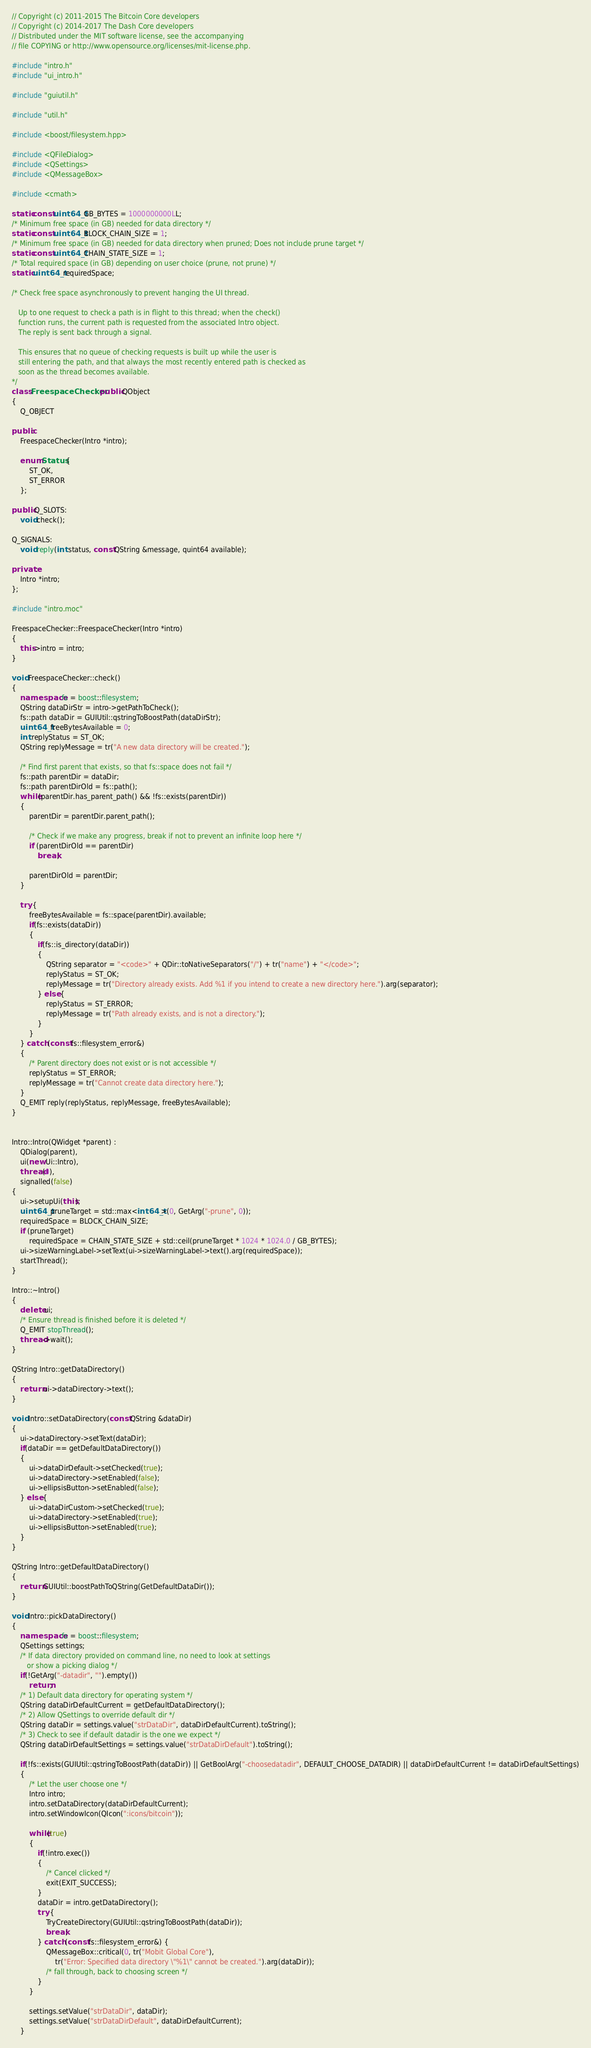Convert code to text. <code><loc_0><loc_0><loc_500><loc_500><_C++_>// Copyright (c) 2011-2015 The Bitcoin Core developers
// Copyright (c) 2014-2017 The Dash Core developers
// Distributed under the MIT software license, see the accompanying
// file COPYING or http://www.opensource.org/licenses/mit-license.php.

#include "intro.h"
#include "ui_intro.h"

#include "guiutil.h"

#include "util.h"

#include <boost/filesystem.hpp>

#include <QFileDialog>
#include <QSettings>
#include <QMessageBox>

#include <cmath>

static const uint64_t GB_BYTES = 1000000000LL;
/* Minimum free space (in GB) needed for data directory */
static const uint64_t BLOCK_CHAIN_SIZE = 1;
/* Minimum free space (in GB) needed for data directory when pruned; Does not include prune target */
static const uint64_t CHAIN_STATE_SIZE = 1;
/* Total required space (in GB) depending on user choice (prune, not prune) */
static uint64_t requiredSpace;

/* Check free space asynchronously to prevent hanging the UI thread.

   Up to one request to check a path is in flight to this thread; when the check()
   function runs, the current path is requested from the associated Intro object.
   The reply is sent back through a signal.

   This ensures that no queue of checking requests is built up while the user is
   still entering the path, and that always the most recently entered path is checked as
   soon as the thread becomes available.
*/
class FreespaceChecker : public QObject
{
    Q_OBJECT

public:
    FreespaceChecker(Intro *intro);

    enum Status {
        ST_OK,
        ST_ERROR
    };

public Q_SLOTS:
    void check();

Q_SIGNALS:
    void reply(int status, const QString &message, quint64 available);

private:
    Intro *intro;
};

#include "intro.moc"

FreespaceChecker::FreespaceChecker(Intro *intro)
{
    this->intro = intro;
}

void FreespaceChecker::check()
{
    namespace fs = boost::filesystem;
    QString dataDirStr = intro->getPathToCheck();
    fs::path dataDir = GUIUtil::qstringToBoostPath(dataDirStr);
    uint64_t freeBytesAvailable = 0;
    int replyStatus = ST_OK;
    QString replyMessage = tr("A new data directory will be created.");

    /* Find first parent that exists, so that fs::space does not fail */
    fs::path parentDir = dataDir;
    fs::path parentDirOld = fs::path();
    while(parentDir.has_parent_path() && !fs::exists(parentDir))
    {
        parentDir = parentDir.parent_path();

        /* Check if we make any progress, break if not to prevent an infinite loop here */
        if (parentDirOld == parentDir)
            break;

        parentDirOld = parentDir;
    }

    try {
        freeBytesAvailable = fs::space(parentDir).available;
        if(fs::exists(dataDir))
        {
            if(fs::is_directory(dataDir))
            {
                QString separator = "<code>" + QDir::toNativeSeparators("/") + tr("name") + "</code>";
                replyStatus = ST_OK;
                replyMessage = tr("Directory already exists. Add %1 if you intend to create a new directory here.").arg(separator);
            } else {
                replyStatus = ST_ERROR;
                replyMessage = tr("Path already exists, and is not a directory.");
            }
        }
    } catch (const fs::filesystem_error&)
    {
        /* Parent directory does not exist or is not accessible */
        replyStatus = ST_ERROR;
        replyMessage = tr("Cannot create data directory here.");
    }
    Q_EMIT reply(replyStatus, replyMessage, freeBytesAvailable);
}


Intro::Intro(QWidget *parent) :
    QDialog(parent),
    ui(new Ui::Intro),
    thread(0),
    signalled(false)
{
    ui->setupUi(this);
    uint64_t pruneTarget = std::max<int64_t>(0, GetArg("-prune", 0));
    requiredSpace = BLOCK_CHAIN_SIZE;
    if (pruneTarget)
        requiredSpace = CHAIN_STATE_SIZE + std::ceil(pruneTarget * 1024 * 1024.0 / GB_BYTES);
    ui->sizeWarningLabel->setText(ui->sizeWarningLabel->text().arg(requiredSpace));
    startThread();
}

Intro::~Intro()
{
    delete ui;
    /* Ensure thread is finished before it is deleted */
    Q_EMIT stopThread();
    thread->wait();
}

QString Intro::getDataDirectory()
{
    return ui->dataDirectory->text();
}

void Intro::setDataDirectory(const QString &dataDir)
{
    ui->dataDirectory->setText(dataDir);
    if(dataDir == getDefaultDataDirectory())
    {
        ui->dataDirDefault->setChecked(true);
        ui->dataDirectory->setEnabled(false);
        ui->ellipsisButton->setEnabled(false);
    } else {
        ui->dataDirCustom->setChecked(true);
        ui->dataDirectory->setEnabled(true);
        ui->ellipsisButton->setEnabled(true);
    }
}

QString Intro::getDefaultDataDirectory()
{
    return GUIUtil::boostPathToQString(GetDefaultDataDir());
}

void Intro::pickDataDirectory()
{
    namespace fs = boost::filesystem;
    QSettings settings;
    /* If data directory provided on command line, no need to look at settings
       or show a picking dialog */
    if(!GetArg("-datadir", "").empty())
        return;
    /* 1) Default data directory for operating system */
    QString dataDirDefaultCurrent = getDefaultDataDirectory();
    /* 2) Allow QSettings to override default dir */
    QString dataDir = settings.value("strDataDir", dataDirDefaultCurrent).toString();
    /* 3) Check to see if default datadir is the one we expect */
    QString dataDirDefaultSettings = settings.value("strDataDirDefault").toString();

    if(!fs::exists(GUIUtil::qstringToBoostPath(dataDir)) || GetBoolArg("-choosedatadir", DEFAULT_CHOOSE_DATADIR) || dataDirDefaultCurrent != dataDirDefaultSettings)
    {
        /* Let the user choose one */
        Intro intro;
        intro.setDataDirectory(dataDirDefaultCurrent);
        intro.setWindowIcon(QIcon(":icons/bitcoin"));

        while(true)
        {
            if(!intro.exec())
            {
                /* Cancel clicked */
                exit(EXIT_SUCCESS);
            }
            dataDir = intro.getDataDirectory();
            try {
                TryCreateDirectory(GUIUtil::qstringToBoostPath(dataDir));
                break;
            } catch (const fs::filesystem_error&) {
                QMessageBox::critical(0, tr("Mobit Global Core"),
                    tr("Error: Specified data directory \"%1\" cannot be created.").arg(dataDir));
                /* fall through, back to choosing screen */
            }
        }

        settings.setValue("strDataDir", dataDir);
        settings.setValue("strDataDirDefault", dataDirDefaultCurrent);
    }</code> 